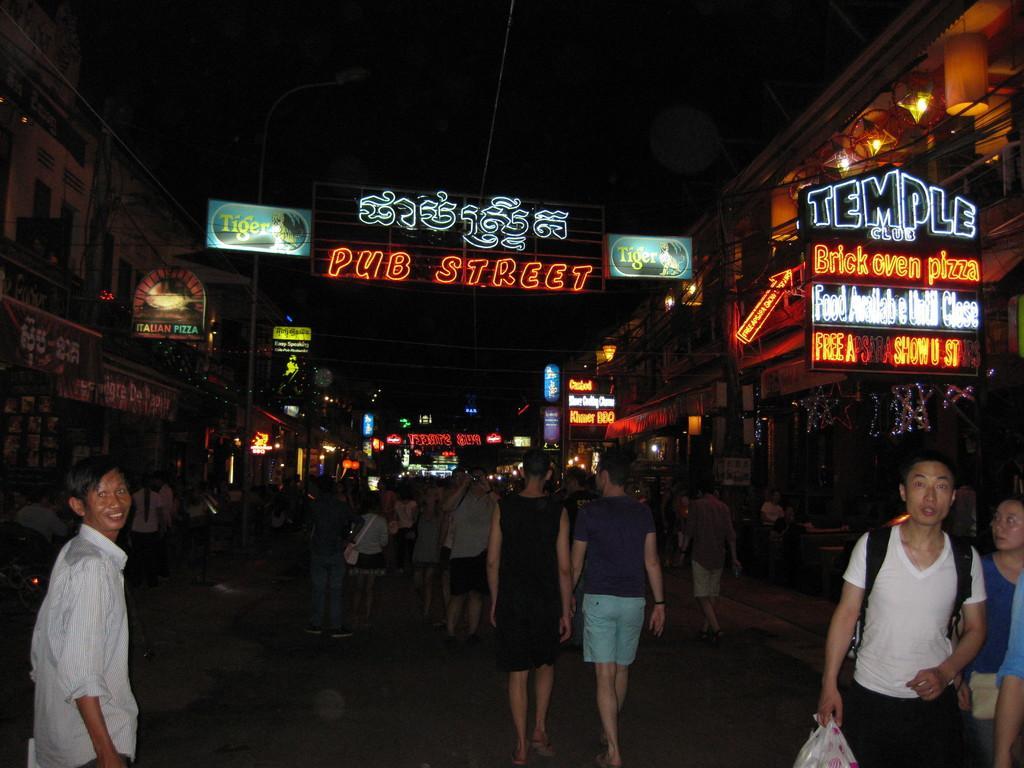How would you summarize this image in a sentence or two? In this picture I can observe some people walking on the road. There are some boards fixed to the walls of the buildings. I can observe some text on the boards. The background is completely dark. 